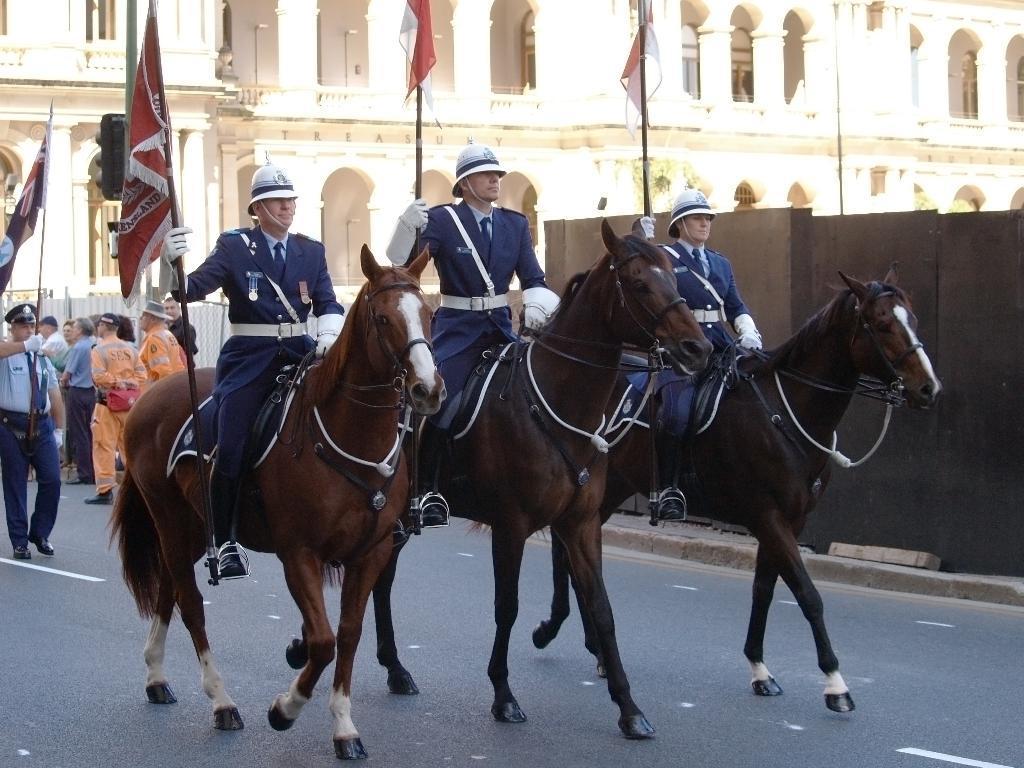In one or two sentences, can you explain what this image depicts? In this picture we can see three horses. We can also see there are three people sitting on each horse. These three people are holding a flag with their hands. In the background we can see a building and few people. Among them one person is holding a flag. We can also see there is a wall. 